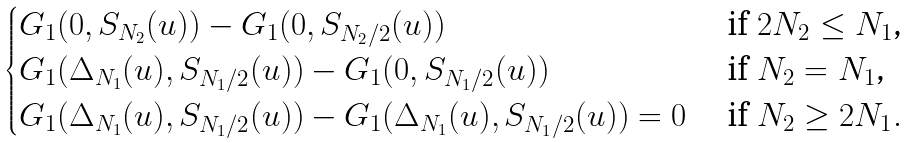<formula> <loc_0><loc_0><loc_500><loc_500>\begin{cases} G _ { 1 } ( 0 , S _ { N _ { 2 } } ( u ) ) - G _ { 1 } ( 0 , S _ { N _ { 2 } / 2 } ( u ) ) & \text { if $2N_{2}\leq N_{1}$,} \\ G _ { 1 } ( \Delta _ { N _ { 1 } } ( u ) , S _ { N _ { 1 } / 2 } ( u ) ) - G _ { 1 } ( 0 , S _ { N _ { 1 } / 2 } ( u ) ) & \text { if $N_{2}=N_{1}$,} \\ G _ { 1 } ( \Delta _ { N _ { 1 } } ( u ) , S _ { N _ { 1 } / 2 } ( u ) ) - G _ { 1 } ( \Delta _ { N _ { 1 } } ( u ) , S _ { N _ { 1 } / 2 } ( u ) ) = 0 & \text { if $N_{2}\geq 2N_{1}$} . \end{cases}</formula> 